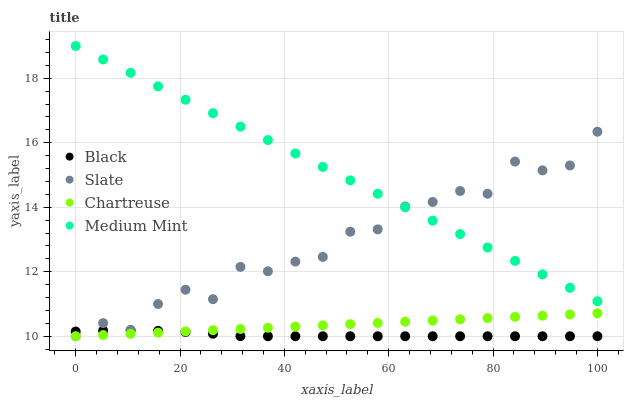Does Black have the minimum area under the curve?
Answer yes or no. Yes. Does Medium Mint have the maximum area under the curve?
Answer yes or no. Yes. Does Slate have the minimum area under the curve?
Answer yes or no. No. Does Slate have the maximum area under the curve?
Answer yes or no. No. Is Medium Mint the smoothest?
Answer yes or no. Yes. Is Slate the roughest?
Answer yes or no. Yes. Is Black the smoothest?
Answer yes or no. No. Is Black the roughest?
Answer yes or no. No. Does Slate have the lowest value?
Answer yes or no. Yes. Does Medium Mint have the highest value?
Answer yes or no. Yes. Does Slate have the highest value?
Answer yes or no. No. Is Chartreuse less than Medium Mint?
Answer yes or no. Yes. Is Medium Mint greater than Chartreuse?
Answer yes or no. Yes. Does Slate intersect Chartreuse?
Answer yes or no. Yes. Is Slate less than Chartreuse?
Answer yes or no. No. Is Slate greater than Chartreuse?
Answer yes or no. No. Does Chartreuse intersect Medium Mint?
Answer yes or no. No. 